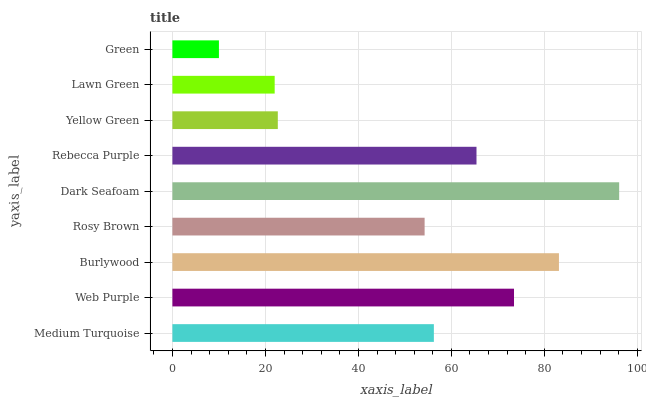Is Green the minimum?
Answer yes or no. Yes. Is Dark Seafoam the maximum?
Answer yes or no. Yes. Is Web Purple the minimum?
Answer yes or no. No. Is Web Purple the maximum?
Answer yes or no. No. Is Web Purple greater than Medium Turquoise?
Answer yes or no. Yes. Is Medium Turquoise less than Web Purple?
Answer yes or no. Yes. Is Medium Turquoise greater than Web Purple?
Answer yes or no. No. Is Web Purple less than Medium Turquoise?
Answer yes or no. No. Is Medium Turquoise the high median?
Answer yes or no. Yes. Is Medium Turquoise the low median?
Answer yes or no. Yes. Is Yellow Green the high median?
Answer yes or no. No. Is Rebecca Purple the low median?
Answer yes or no. No. 